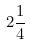<formula> <loc_0><loc_0><loc_500><loc_500>2 \frac { 1 } { 4 }</formula> 